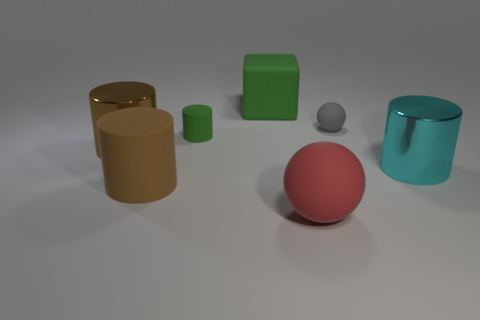Subtract all small green matte cylinders. How many cylinders are left? 3 Add 1 matte objects. How many objects exist? 8 Subtract all green cubes. How many brown cylinders are left? 2 Subtract all cylinders. How many objects are left? 3 Subtract 1 cubes. How many cubes are left? 0 Add 1 metallic things. How many metallic things are left? 3 Add 1 matte things. How many matte things exist? 6 Subtract all green cylinders. How many cylinders are left? 3 Subtract 0 brown spheres. How many objects are left? 7 Subtract all purple cylinders. Subtract all purple blocks. How many cylinders are left? 4 